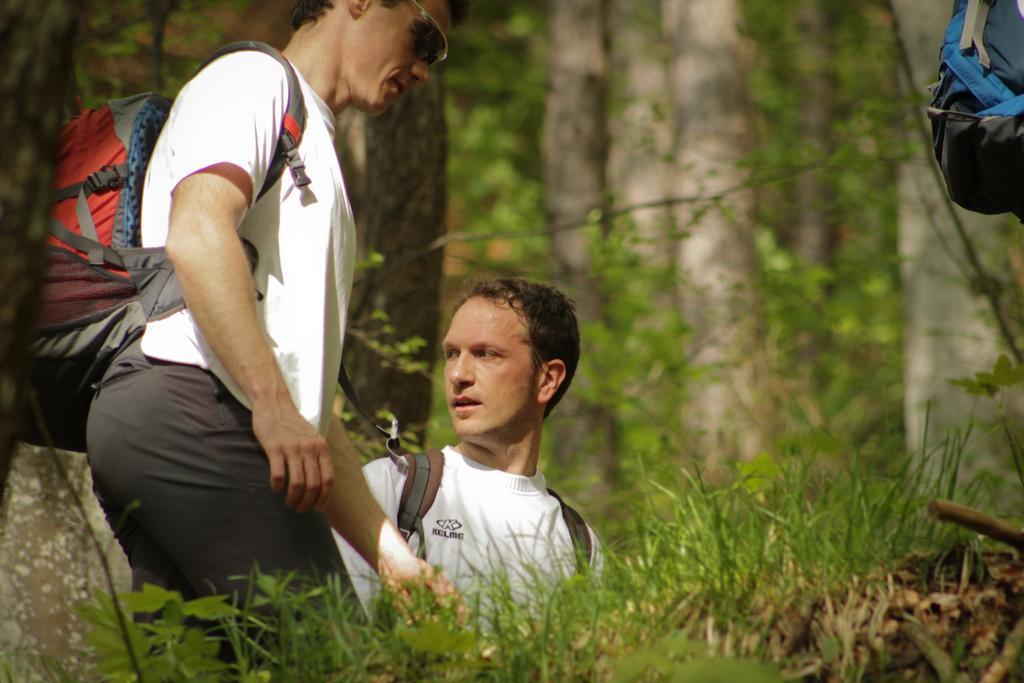Could you give a brief overview of what you see in this image? In this image, we can see two people are wearing backpacks. At the bottom, we can see grass and plants. Background there are so many trees, stems, leaves we can see. Right side top corner, there is a backpack we can see. 